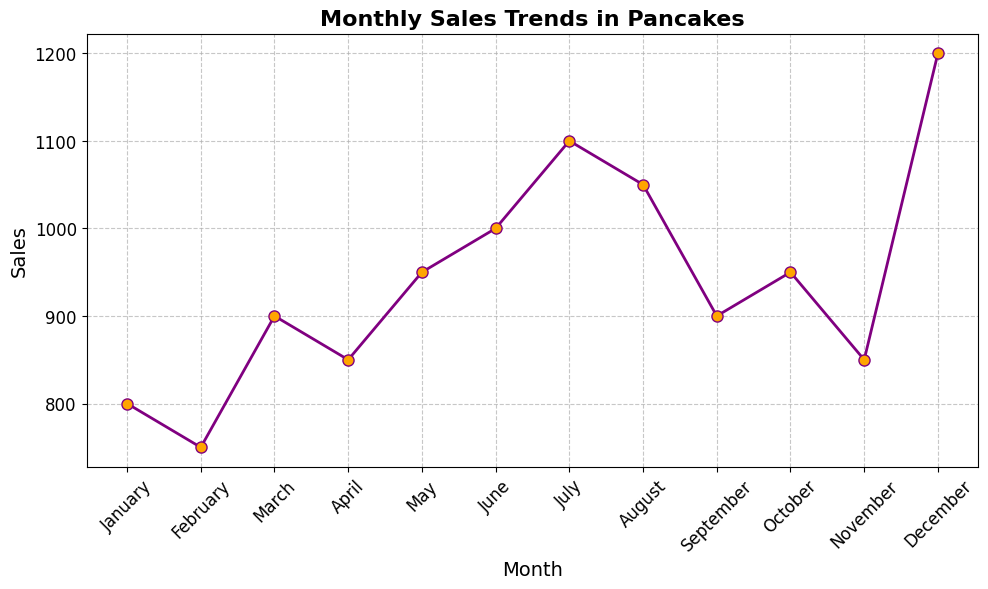Which month had the highest sales? The highest point on the line chart corresponds to December, with 1200 sales.
Answer: December What is the difference in sales between the month with the highest sales and the month with the lowest sales? The highest sales are in December (1200) and the lowest sales are in February (750). The difference is 1200 - 750 = 450.
Answer: 450 In which month(s) did sales exceed 1000? Looking at the chart, the months where sales exceed 1000 are July (1100) and December (1200).
Answer: July, December How do the sales in March compare to those in May? March has 900 sales, and May has 950 sales. May's sales are higher than March's sales by 950 - 900 = 50.
Answer: May's sales are higher by 50 What is the average sales for the first six months of the year (January to June)? Sum the sales from January through June: 800 + 750 + 900 + 850 + 950 + 1000 = 5250. Divide by 6 to find the average: 5250 / 6 = 875.
Answer: 875 Identify one season with a notable increase or decrease in sales. Comparing different seasons, summer (June, July, August) shows a notably increasing trend, peaking in July at 1100 sales.
Answer: Summer (Notable Increase) Which month shows a dip in sales after a steady rise? Sales rise steadily from March (900) to July (1100) and show a dip in August (1050).
Answer: August What are the total sales for the last quarter of the year (October to December)? Sum the sales from October to December: 950 + 850 + 1200 = 3000.
Answer: 3000 Compare the sales trends between the months of February and November. Both months show sales of 750 in February and 850 in November, with November having higher sales. So, November has 100 sales more than February.
Answer: November's sales are higher by 100 